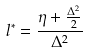<formula> <loc_0><loc_0><loc_500><loc_500>l ^ { * } = \frac { \eta + \frac { \Delta ^ { 2 } } { 2 } } { \Delta ^ { 2 } }</formula> 